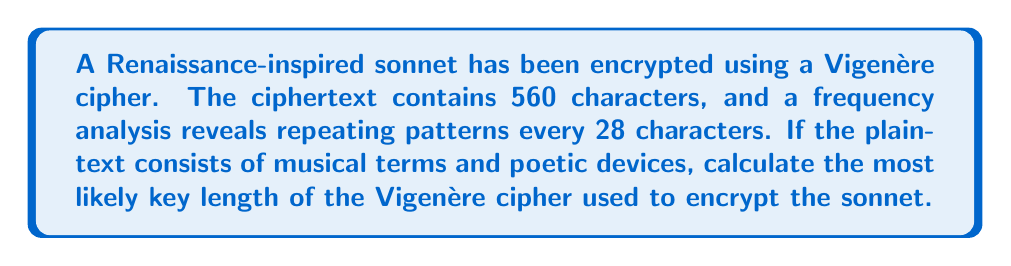Could you help me with this problem? To determine the most likely key length of a Vigenère cipher, we need to analyze the repeating patterns in the ciphertext. The key length is typically a factor of the distance between these repeating patterns.

Step 1: Identify the distance between repeating patterns
Given: Repeating patterns occur every 28 characters

Step 2: List the factors of 28
Factors of 28 = {1, 2, 4, 7, 14, 28}

Step 3: Consider the context
Since the plaintext consists of musical terms and poetic devices, we can assume that the key is likely to be a word or short phrase related to music or poetry. The most probable key lengths are therefore the middle-range factors.

Step 4: Eliminate unlikely options
- 1 and 2 are too short for a meaningful key
- 28 is too long for a practical key in this context

Step 5: Choose the most likely key length
Among the remaining options (4, 7, 14), 7 is the most probable key length as it's neither too short nor too long for a word or short phrase related to music or poetry.

Therefore, the most likely key length for this Vigenère cipher is 7 characters.
Answer: 7 